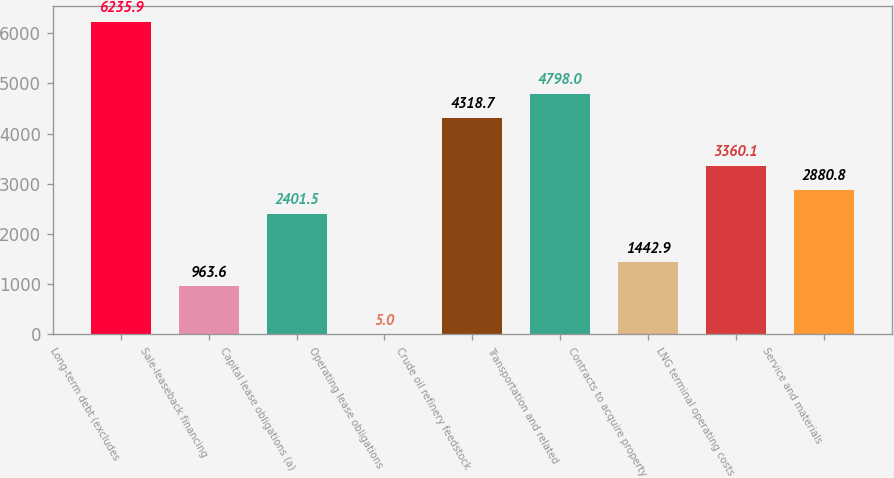<chart> <loc_0><loc_0><loc_500><loc_500><bar_chart><fcel>Long-term debt (excludes<fcel>Sale-leaseback financing<fcel>Capital lease obligations (a)<fcel>Operating lease obligations<fcel>Crude oil refinery feedstock<fcel>Transportation and related<fcel>Contracts to acquire property<fcel>LNG terminal operating costs<fcel>Service and materials<nl><fcel>6235.9<fcel>963.6<fcel>2401.5<fcel>5<fcel>4318.7<fcel>4798<fcel>1442.9<fcel>3360.1<fcel>2880.8<nl></chart> 